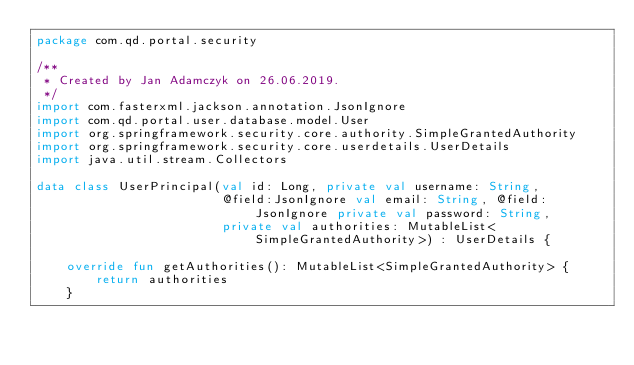<code> <loc_0><loc_0><loc_500><loc_500><_Kotlin_>package com.qd.portal.security

/**
 * Created by Jan Adamczyk on 26.06.2019.
 */
import com.fasterxml.jackson.annotation.JsonIgnore
import com.qd.portal.user.database.model.User
import org.springframework.security.core.authority.SimpleGrantedAuthority
import org.springframework.security.core.userdetails.UserDetails
import java.util.stream.Collectors

data class UserPrincipal(val id: Long, private val username: String,
                         @field:JsonIgnore val email: String, @field:JsonIgnore private val password: String,
                         private val authorities: MutableList<SimpleGrantedAuthority>) : UserDetails {

    override fun getAuthorities(): MutableList<SimpleGrantedAuthority> {
        return authorities
    }
</code> 